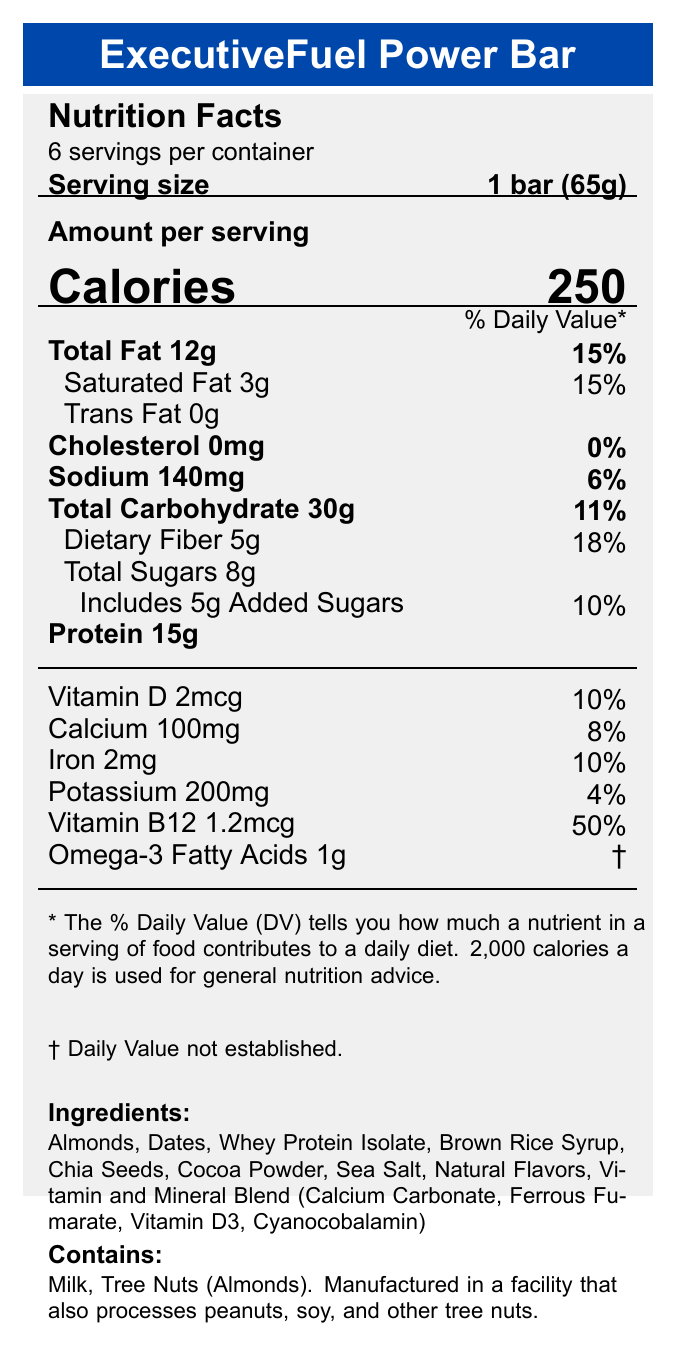what is the serving size for the ExecutiveFuel Power Bar? The document states that the serving size is "1 bar (65g)".
Answer: 1 bar (65g) how many calories are there in one serving of the ExecutiveFuel Power Bar? The document specifies that there are 250 calories per serving.
Answer: 250 what percentage of the daily value of dietary fiber does one serving provide? According to the document, one serving provides 18% of the daily value for dietary fiber.
Answer: 18% what is the amount of total sugars in one serving? The document shows that the total sugars amount to 8g per serving.
Answer: 8g how many grams of protein are in one bar? The document lists the protein amount as 15g per serving.
Answer: 15g which allergen is not listed as an ingredient in the ExecutiveFuel Power Bar? A. Milk B. Tree Nuts C. Eggs D. Peanuts The document states the allergens "Contains: Milk, Tree Nuts (Almonds)" and mentions manufacturing in a facility processing peanuts, soy, and other tree nuts, but does not mention eggs.
Answer: C. Eggs what is the percentage of the daily value for calcium provided by one serving? A. 4% B. 8% C. 10% D. 15% The document lists 100mg of calcium, which is 8% of the daily value.
Answer: B. 8% does the ExecutiveFuel Power Bar contain any trans fat? The document mentions that Trans Fat is "0g".
Answer: No how long can the ExecutiveFuel Power Bar be stored for best quality? The storage instructions state that for best quality, consume before the date printed on the package.
Answer: Before the date printed on the package does the ExecutiveFuel Power Bar contain artificial preservatives or colors? The marketing claims state "No artificial preservatives or colors".
Answer: No summarize the main idea of the document. The document is a comprehensive overview of the nutritional and ingredient information for the ExecutiveFuel Power Bar, along with allergy warnings and storage instructions.
Answer: The document provides the nutrition facts, ingredient list, allergens, and storage instructions for the ExecutiveFuel Power Bar. It highlights key nutritional values such as calories, fats, protein, vitamins, and minerals per serving, and emphasizes its marketing claims focusing on high protein, brain-boosting omega-3 fatty acids, fiber content, and lack of artificial preservatives or colors. how many servings are there per container? The document states that there are 6 servings per container.
Answer: 6 how much Vitamin B12 is in one serving? The Vitamin B12 content is listed as 1.2mcg per serving.
Answer: 1.2mcg are there any artificial flavors in the ExecutiveFuel Power Bar? The document lists "Natural Flavors" in the ingredients but does not specify whether artificial flavors are included or not.
Answer: I don't know what is the amount of omega-3 fatty acids in one serving? The document states there is 1g of omega-3 fatty acids per serving.
Answer: 1g 